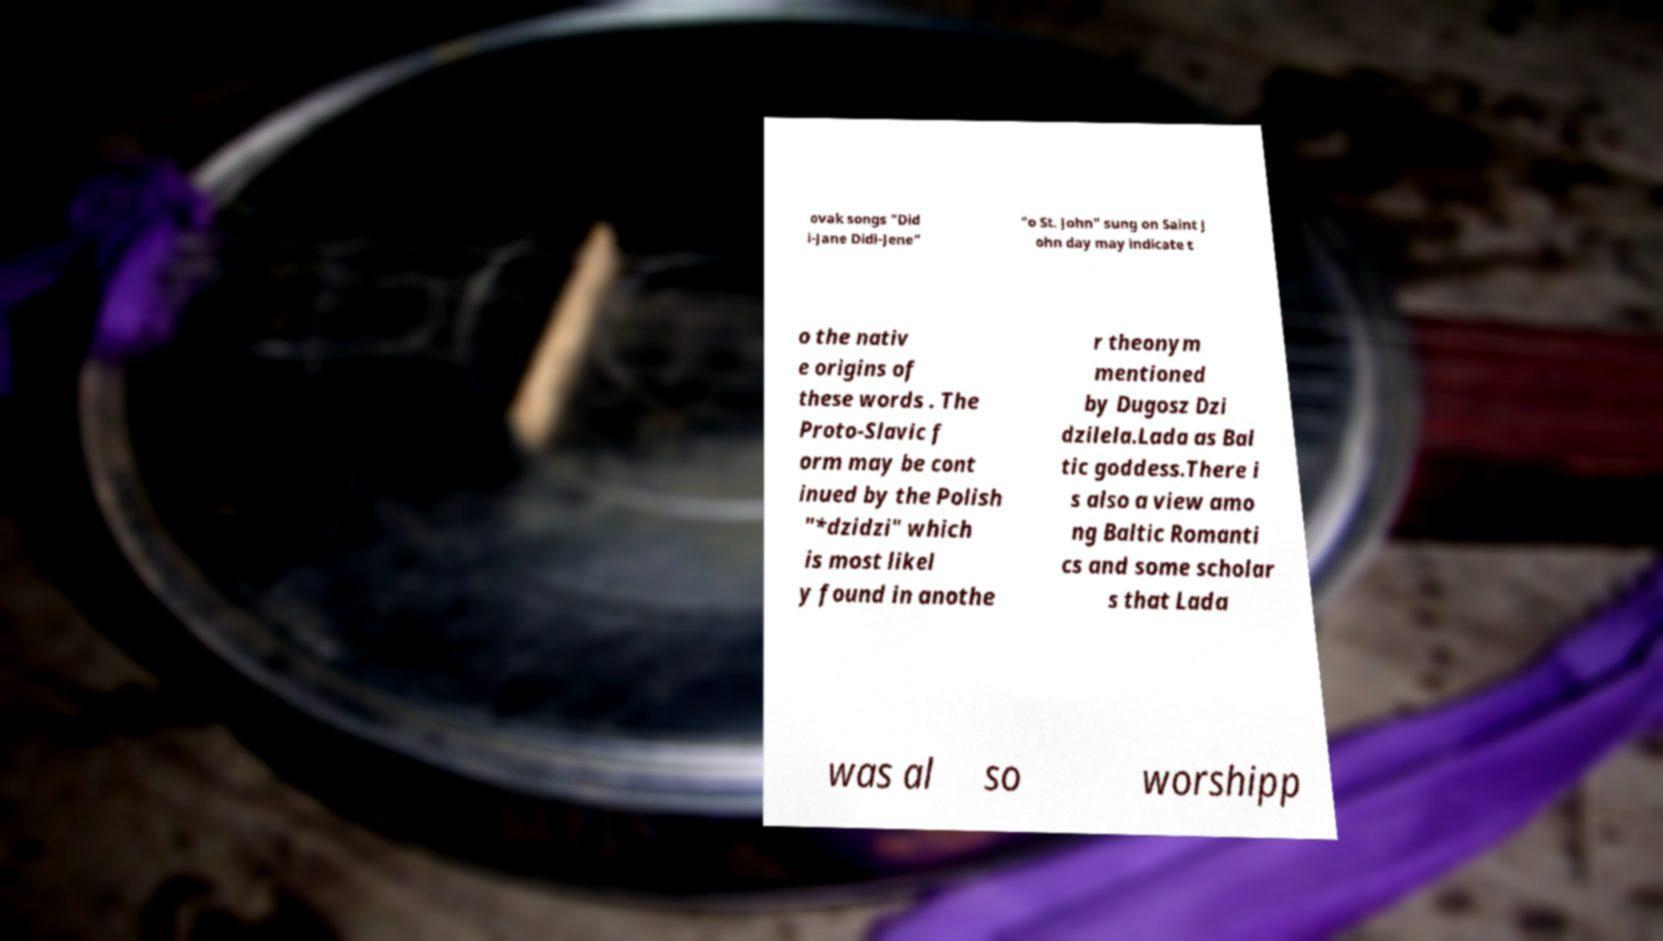Please identify and transcribe the text found in this image. ovak songs "Did i-Jane Didi-Jene" "o St. John" sung on Saint J ohn day may indicate t o the nativ e origins of these words . The Proto-Slavic f orm may be cont inued by the Polish "*dzidzi" which is most likel y found in anothe r theonym mentioned by Dugosz Dzi dzilela.Lada as Bal tic goddess.There i s also a view amo ng Baltic Romanti cs and some scholar s that Lada was al so worshipp 